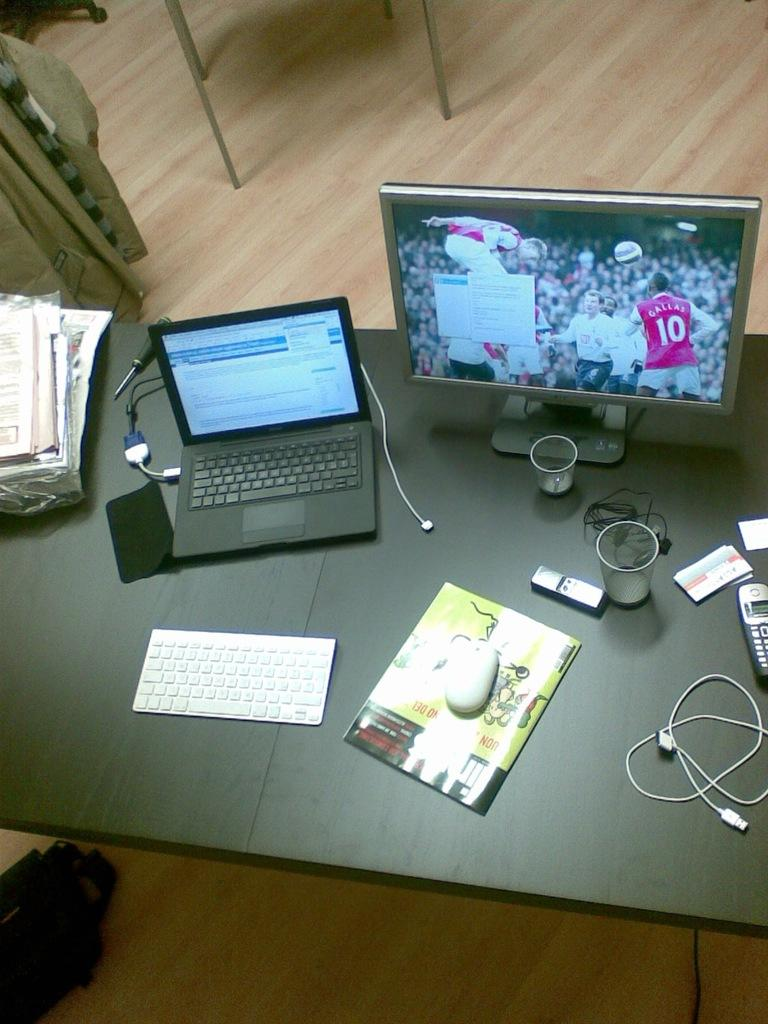<image>
Give a short and clear explanation of the subsequent image. A monitor with an image of a number 10 soccer player is on a table next to a laptop. 